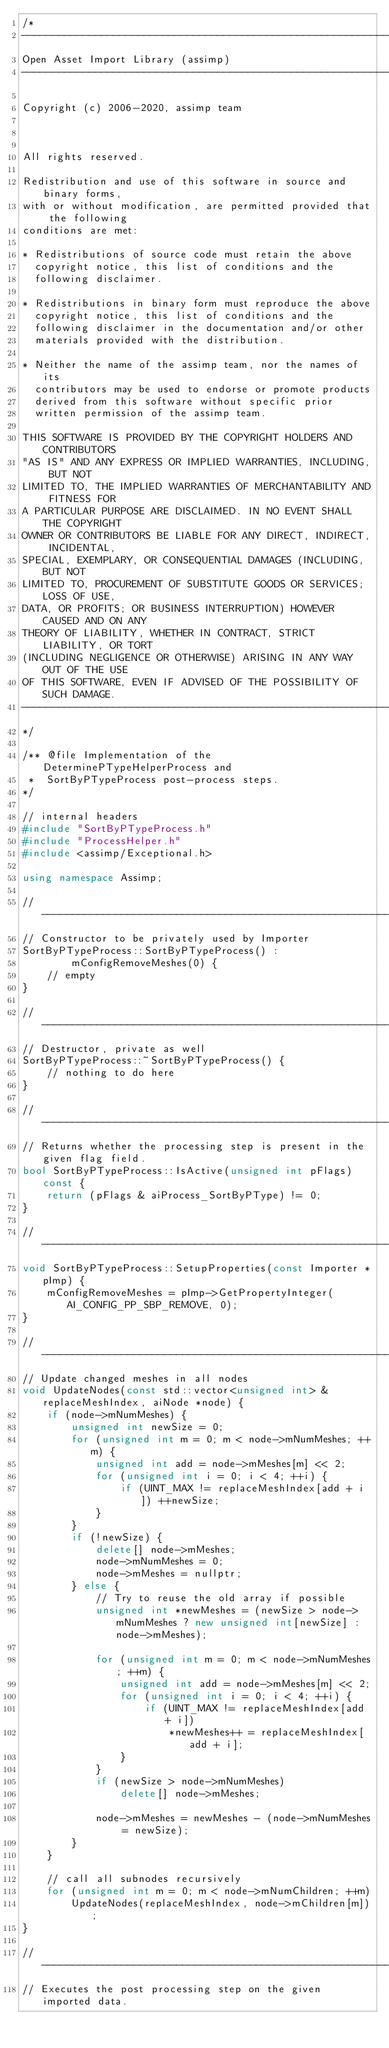<code> <loc_0><loc_0><loc_500><loc_500><_C++_>/*
---------------------------------------------------------------------------
Open Asset Import Library (assimp)
---------------------------------------------------------------------------

Copyright (c) 2006-2020, assimp team



All rights reserved.

Redistribution and use of this software in source and binary forms,
with or without modification, are permitted provided that the following
conditions are met:

* Redistributions of source code must retain the above
  copyright notice, this list of conditions and the
  following disclaimer.

* Redistributions in binary form must reproduce the above
  copyright notice, this list of conditions and the
  following disclaimer in the documentation and/or other
  materials provided with the distribution.

* Neither the name of the assimp team, nor the names of its
  contributors may be used to endorse or promote products
  derived from this software without specific prior
  written permission of the assimp team.

THIS SOFTWARE IS PROVIDED BY THE COPYRIGHT HOLDERS AND CONTRIBUTORS
"AS IS" AND ANY EXPRESS OR IMPLIED WARRANTIES, INCLUDING, BUT NOT
LIMITED TO, THE IMPLIED WARRANTIES OF MERCHANTABILITY AND FITNESS FOR
A PARTICULAR PURPOSE ARE DISCLAIMED. IN NO EVENT SHALL THE COPYRIGHT
OWNER OR CONTRIBUTORS BE LIABLE FOR ANY DIRECT, INDIRECT, INCIDENTAL,
SPECIAL, EXEMPLARY, OR CONSEQUENTIAL DAMAGES (INCLUDING, BUT NOT
LIMITED TO, PROCUREMENT OF SUBSTITUTE GOODS OR SERVICES; LOSS OF USE,
DATA, OR PROFITS; OR BUSINESS INTERRUPTION) HOWEVER CAUSED AND ON ANY
THEORY OF LIABILITY, WHETHER IN CONTRACT, STRICT LIABILITY, OR TORT
(INCLUDING NEGLIGENCE OR OTHERWISE) ARISING IN ANY WAY OUT OF THE USE
OF THIS SOFTWARE, EVEN IF ADVISED OF THE POSSIBILITY OF SUCH DAMAGE.
---------------------------------------------------------------------------
*/

/** @file Implementation of the DeterminePTypeHelperProcess and
 *  SortByPTypeProcess post-process steps.
*/

// internal headers
#include "SortByPTypeProcess.h"
#include "ProcessHelper.h"
#include <assimp/Exceptional.h>

using namespace Assimp;

// ------------------------------------------------------------------------------------------------
// Constructor to be privately used by Importer
SortByPTypeProcess::SortByPTypeProcess() :
        mConfigRemoveMeshes(0) {
    // empty
}

// ------------------------------------------------------------------------------------------------
// Destructor, private as well
SortByPTypeProcess::~SortByPTypeProcess() {
    // nothing to do here
}

// ------------------------------------------------------------------------------------------------
// Returns whether the processing step is present in the given flag field.
bool SortByPTypeProcess::IsActive(unsigned int pFlags) const {
    return (pFlags & aiProcess_SortByPType) != 0;
}

// ------------------------------------------------------------------------------------------------
void SortByPTypeProcess::SetupProperties(const Importer *pImp) {
    mConfigRemoveMeshes = pImp->GetPropertyInteger(AI_CONFIG_PP_SBP_REMOVE, 0);
}

// ------------------------------------------------------------------------------------------------
// Update changed meshes in all nodes
void UpdateNodes(const std::vector<unsigned int> &replaceMeshIndex, aiNode *node) {
    if (node->mNumMeshes) {
        unsigned int newSize = 0;
        for (unsigned int m = 0; m < node->mNumMeshes; ++m) {
            unsigned int add = node->mMeshes[m] << 2;
            for (unsigned int i = 0; i < 4; ++i) {
                if (UINT_MAX != replaceMeshIndex[add + i]) ++newSize;
            }
        }
        if (!newSize) {
            delete[] node->mMeshes;
            node->mNumMeshes = 0;
            node->mMeshes = nullptr;
        } else {
            // Try to reuse the old array if possible
            unsigned int *newMeshes = (newSize > node->mNumMeshes ? new unsigned int[newSize] : node->mMeshes);

            for (unsigned int m = 0; m < node->mNumMeshes; ++m) {
                unsigned int add = node->mMeshes[m] << 2;
                for (unsigned int i = 0; i < 4; ++i) {
                    if (UINT_MAX != replaceMeshIndex[add + i])
                        *newMeshes++ = replaceMeshIndex[add + i];
                }
            }
            if (newSize > node->mNumMeshes)
                delete[] node->mMeshes;

            node->mMeshes = newMeshes - (node->mNumMeshes = newSize);
        }
    }

    // call all subnodes recursively
    for (unsigned int m = 0; m < node->mNumChildren; ++m)
        UpdateNodes(replaceMeshIndex, node->mChildren[m]);
}

// ------------------------------------------------------------------------------------------------
// Executes the post processing step on the given imported data.</code> 